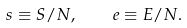<formula> <loc_0><loc_0><loc_500><loc_500>s \equiv S / N , \quad e \equiv E / N .</formula> 